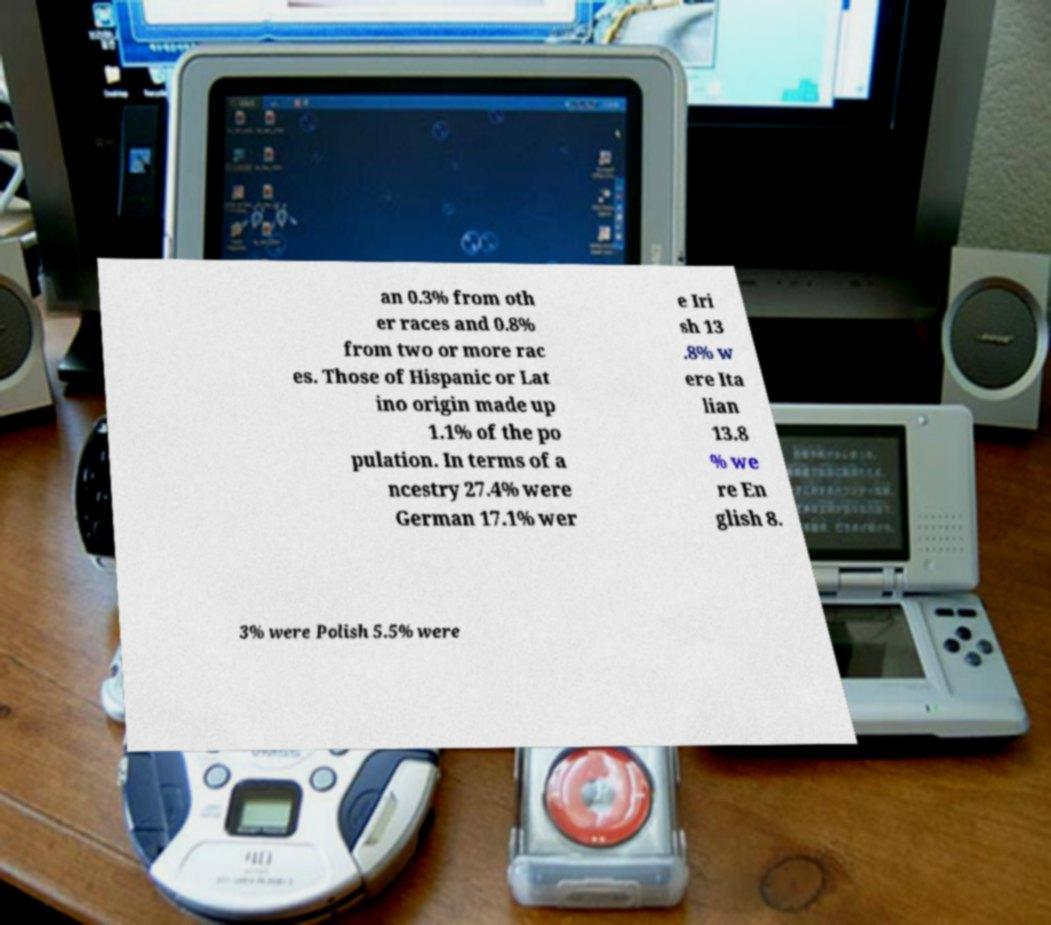Can you read and provide the text displayed in the image?This photo seems to have some interesting text. Can you extract and type it out for me? an 0.3% from oth er races and 0.8% from two or more rac es. Those of Hispanic or Lat ino origin made up 1.1% of the po pulation. In terms of a ncestry 27.4% were German 17.1% wer e Iri sh 13 .8% w ere Ita lian 13.8 % we re En glish 8. 3% were Polish 5.5% were 